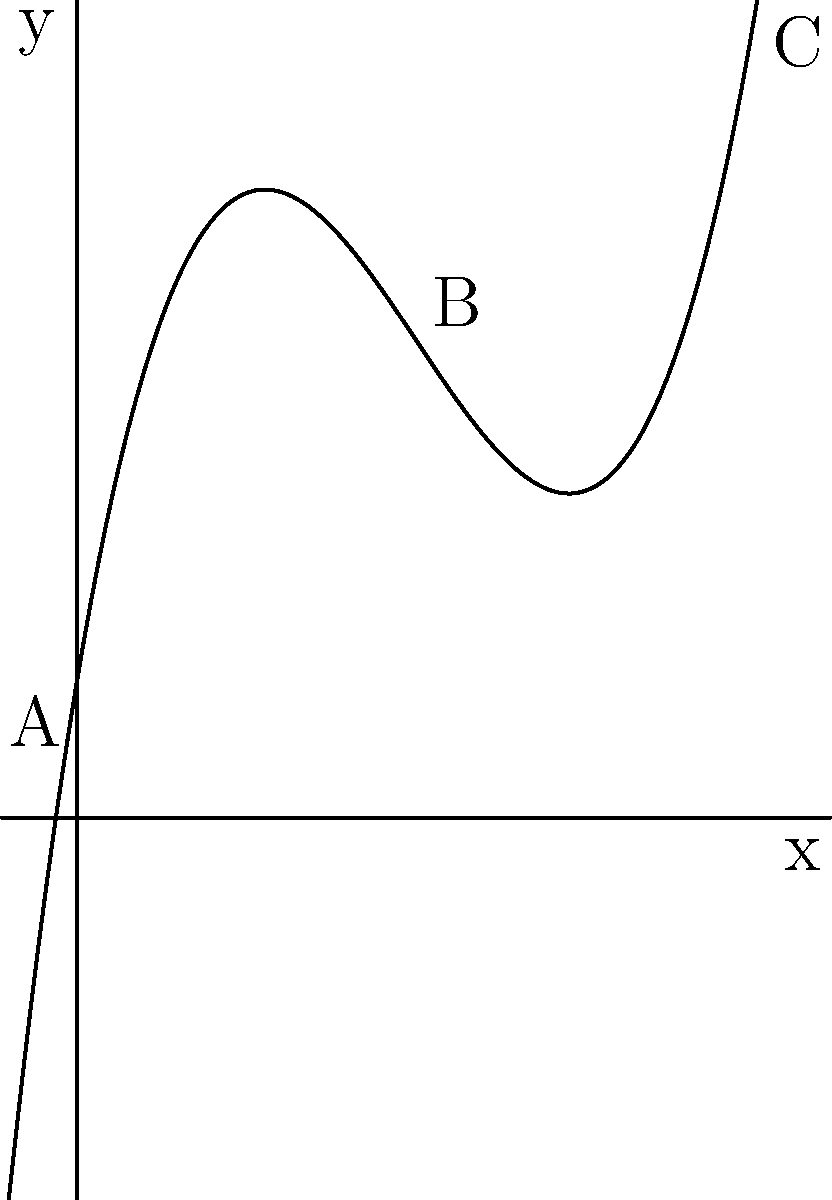As an interior designer, you're analyzing the ergonomic curve of a chair's backrest, represented by the polynomial function $f(x) = 0.1x^3 - 1.5x^2 + 6x + 2$. The x-axis represents the horizontal distance from the chair's base, and the y-axis represents the vertical height. What is the rate of change in the backrest's curvature between points A (0,2) and C (10,52)? To find the rate of change between points A and C, we need to follow these steps:

1. Identify the coordinates of points A and C:
   A(0, 2) and C(10, 52)

2. Calculate the change in y (vertical height):
   $\Delta y = y_C - y_A = 52 - 2 = 50$

3. Calculate the change in x (horizontal distance):
   $\Delta x = x_C - x_A = 10 - 0 = 10$

4. Calculate the rate of change using the slope formula:
   Rate of change = $\frac{\Delta y}{\Delta x} = \frac{50}{10} = 5$

This means that, on average, the backrest's height increases by 5 units for every 1 unit of horizontal distance between points A and C.
Answer: 5 units per unit distance 